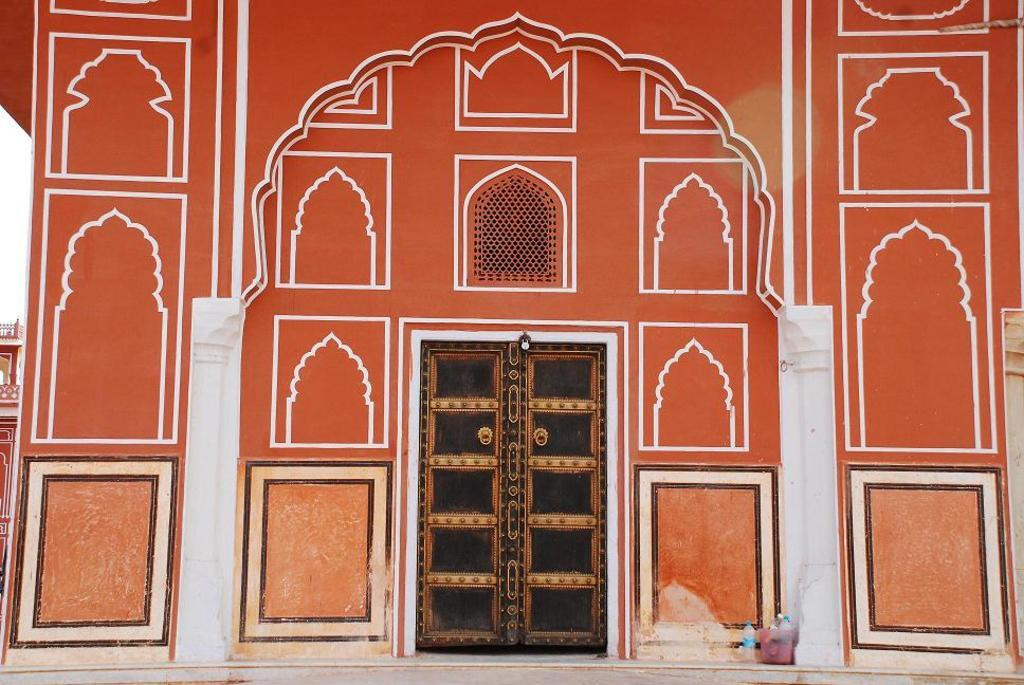Where was the image taken? The image is taken outdoors. What can be seen on the wall in the image? There is a wall with a painting in the image. What architectural feature is present in the image? There is a door in the image. What surface is visible underfoot in the image? There is a floor visible in the image. What objects are on the floor in the image? There are a few bottles on the floor. Who gave their approval for the painting on the wall in the image? The image does not provide information about who approved the painting on the wall. What does the throne in the image taste like? There is no throne present in the image. 